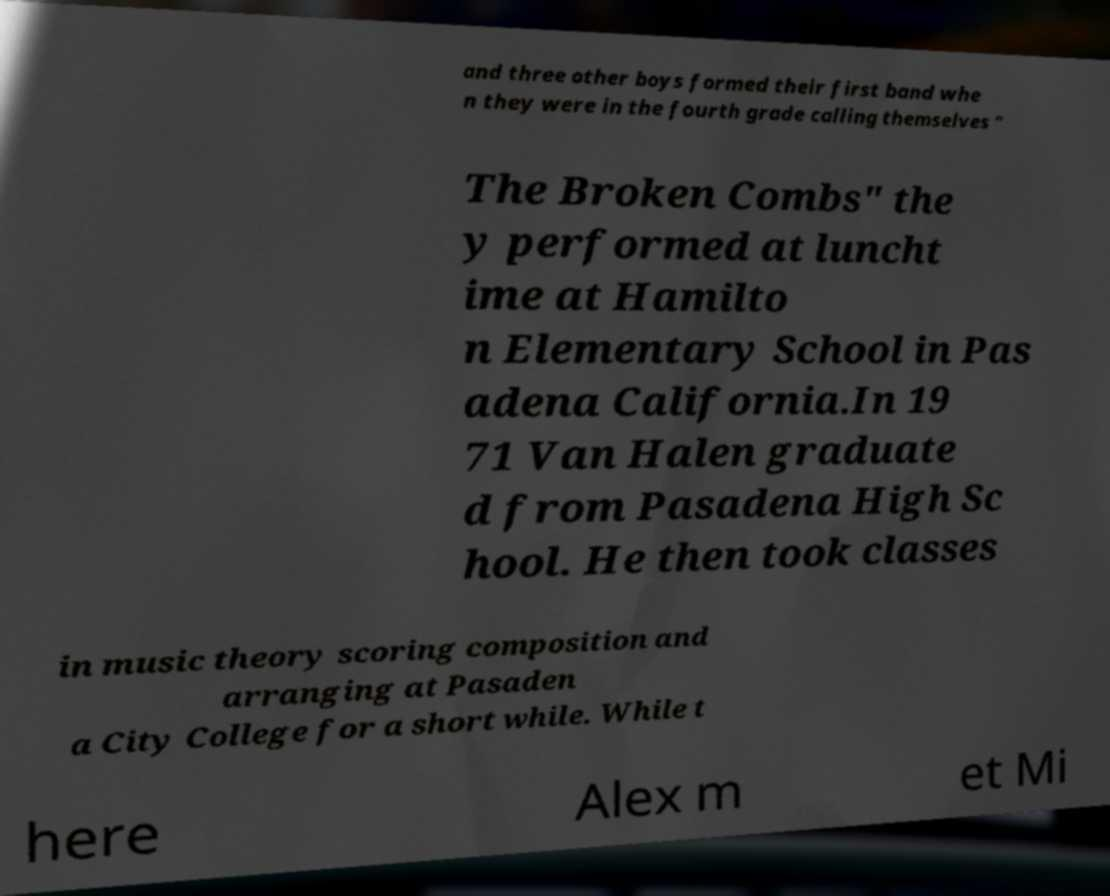Could you assist in decoding the text presented in this image and type it out clearly? and three other boys formed their first band whe n they were in the fourth grade calling themselves " The Broken Combs" the y performed at luncht ime at Hamilto n Elementary School in Pas adena California.In 19 71 Van Halen graduate d from Pasadena High Sc hool. He then took classes in music theory scoring composition and arranging at Pasaden a City College for a short while. While t here Alex m et Mi 